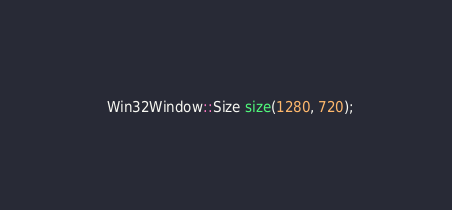<code> <loc_0><loc_0><loc_500><loc_500><_C++_>  Win32Window::Size size(1280, 720);</code> 